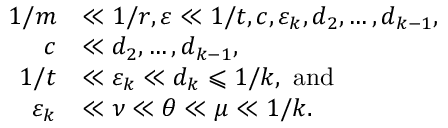<formula> <loc_0><loc_0><loc_500><loc_500>\begin{array} { r l } { 1 / m } & { \ll 1 / r , \varepsilon \ll 1 / t , c , \varepsilon _ { k } , d _ { 2 } , \dots , d _ { k - 1 } , } \\ { c } & { \ll d _ { 2 } , \dots , d _ { k - 1 } , } \\ { 1 / t } & { \ll \varepsilon _ { k } \ll d _ { k } \leqslant 1 / k , a n d } \\ { \varepsilon _ { k } } & { \ll \nu \ll { \theta } \ll \mu \ll 1 / k . } \end{array}</formula> 